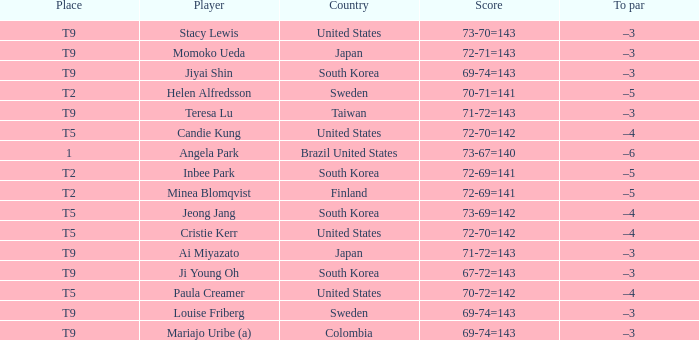Which country placed t9 and had the player jiyai shin? South Korea. 